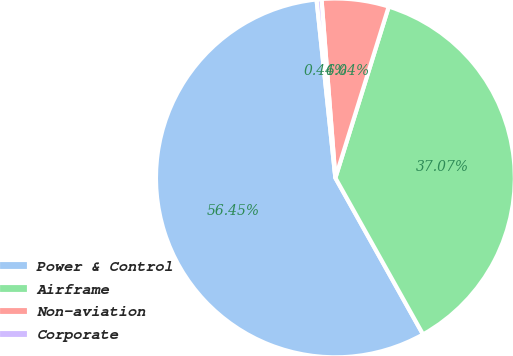<chart> <loc_0><loc_0><loc_500><loc_500><pie_chart><fcel>Power & Control<fcel>Airframe<fcel>Non-aviation<fcel>Corporate<nl><fcel>56.45%<fcel>37.07%<fcel>6.04%<fcel>0.44%<nl></chart> 